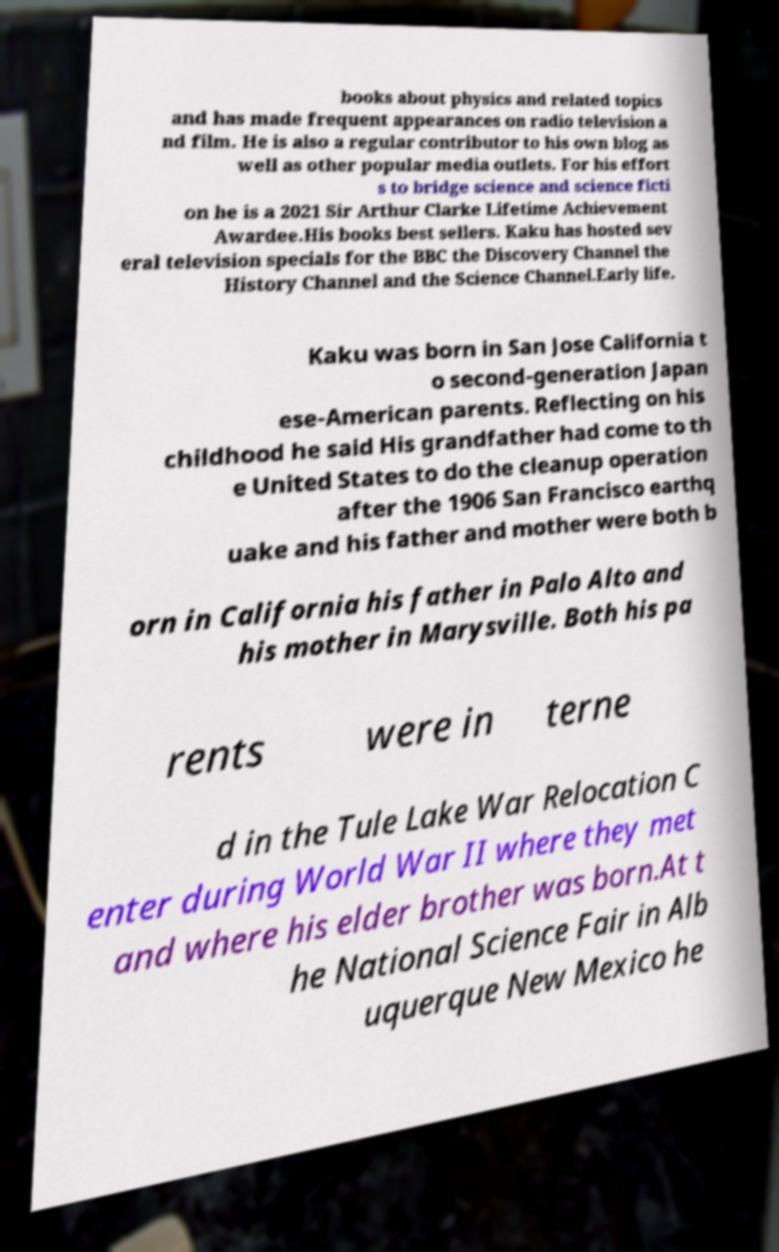Could you extract and type out the text from this image? books about physics and related topics and has made frequent appearances on radio television a nd film. He is also a regular contributor to his own blog as well as other popular media outlets. For his effort s to bridge science and science ficti on he is a 2021 Sir Arthur Clarke Lifetime Achievement Awardee.His books best sellers. Kaku has hosted sev eral television specials for the BBC the Discovery Channel the History Channel and the Science Channel.Early life. Kaku was born in San Jose California t o second-generation Japan ese-American parents. Reflecting on his childhood he said His grandfather had come to th e United States to do the cleanup operation after the 1906 San Francisco earthq uake and his father and mother were both b orn in California his father in Palo Alto and his mother in Marysville. Both his pa rents were in terne d in the Tule Lake War Relocation C enter during World War II where they met and where his elder brother was born.At t he National Science Fair in Alb uquerque New Mexico he 